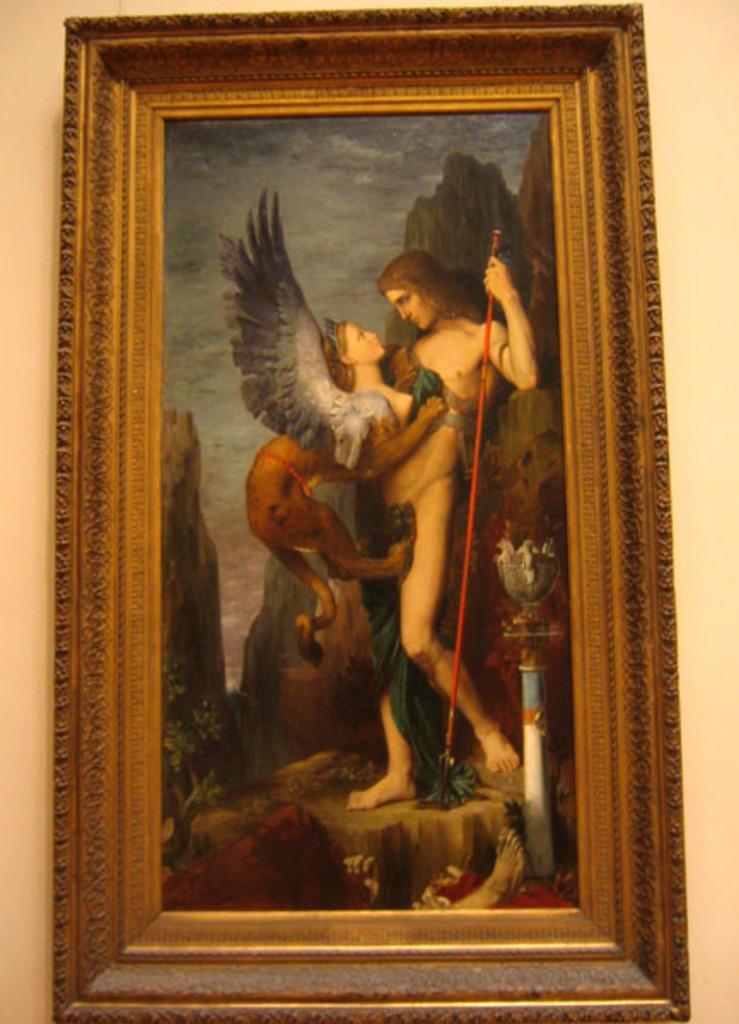How would you summarize this image in a sentence or two? In this image we can see a photo frame on the wall. There is a painting in the image. In painting we can see few people, few hills, a sky and few plants. 